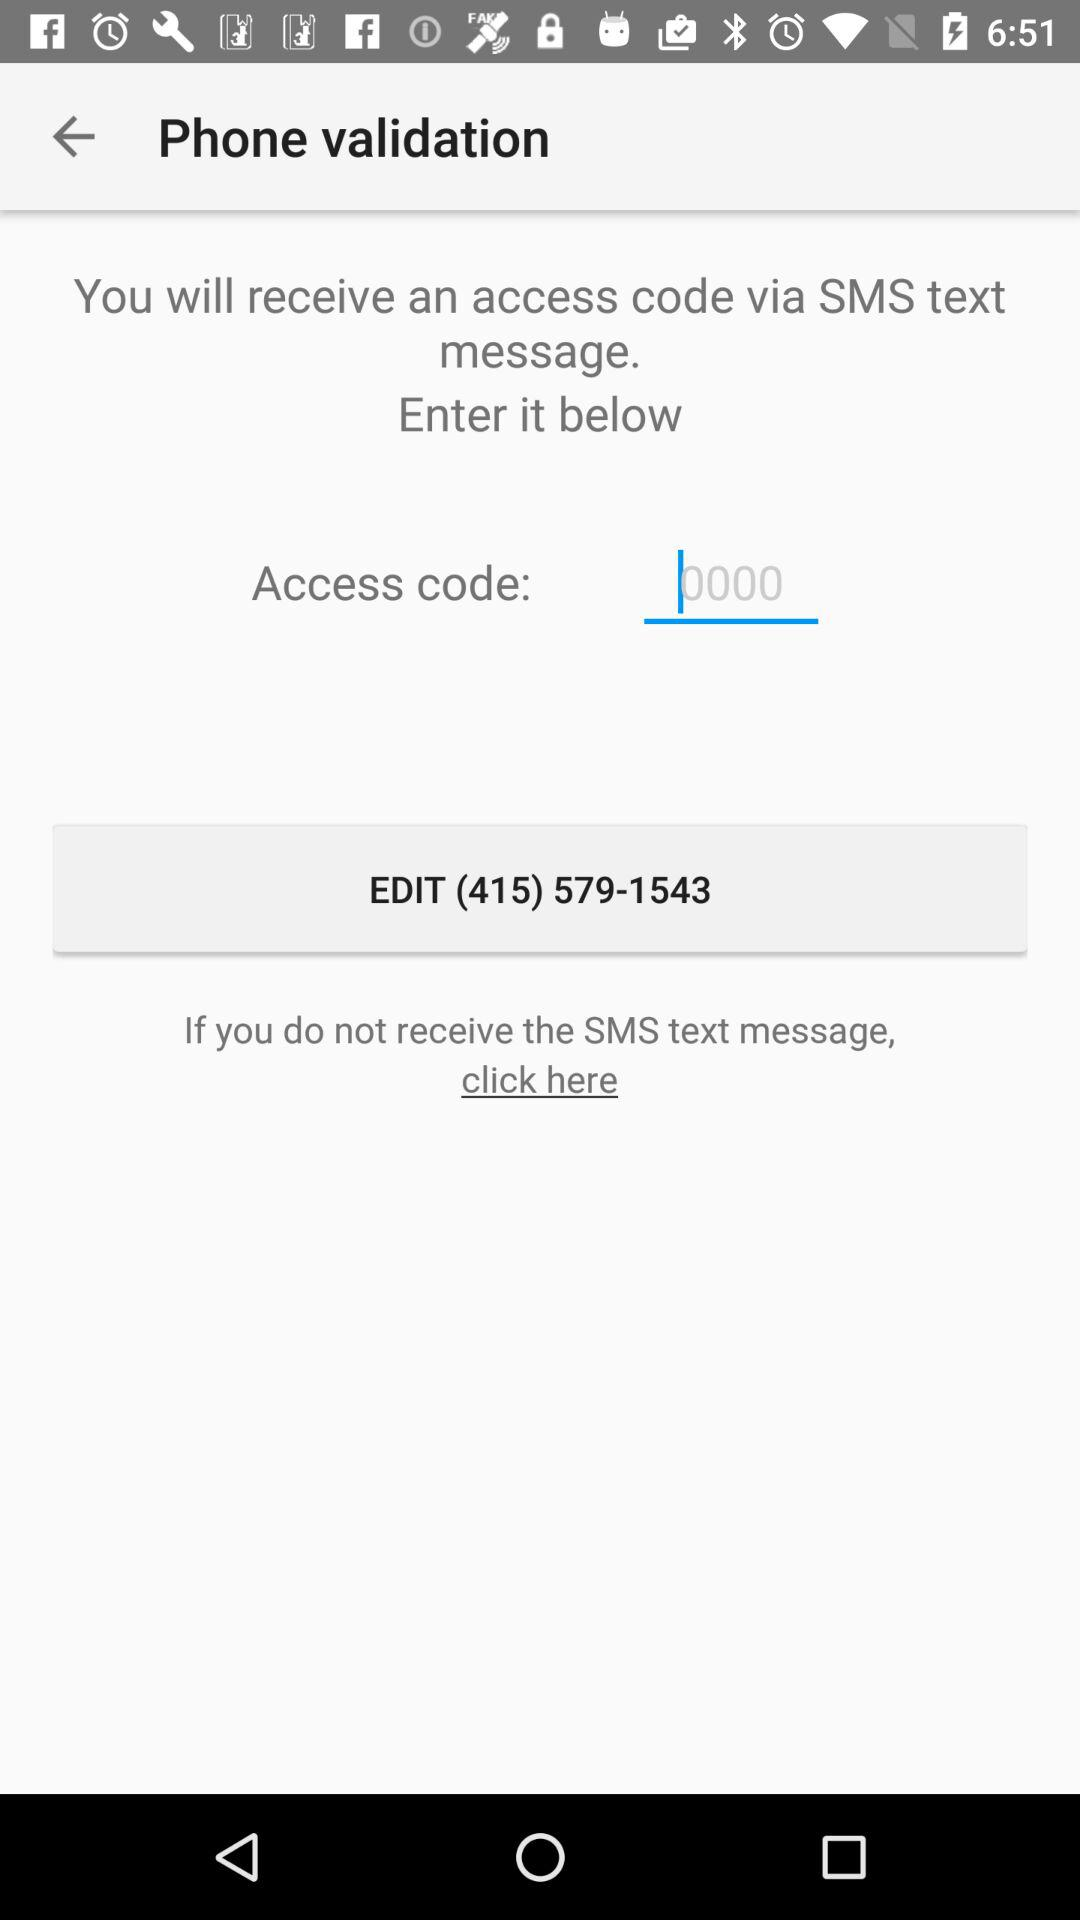Through what can I receive an access code? You can receive an access code via SMS text message. 